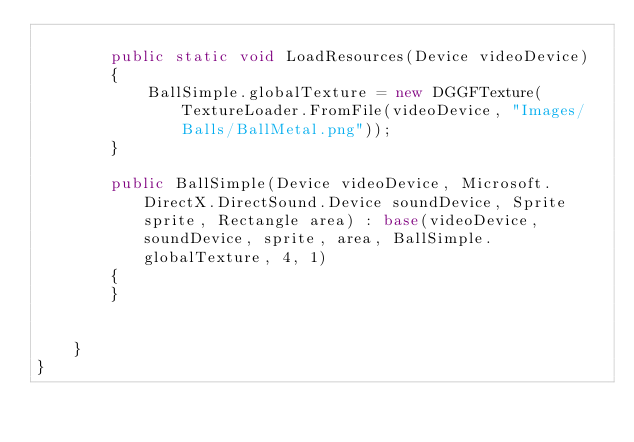Convert code to text. <code><loc_0><loc_0><loc_500><loc_500><_C#_>
		public static void LoadResources(Device videoDevice)
		{
			BallSimple.globalTexture = new DGGFTexture(TextureLoader.FromFile(videoDevice, "Images/Balls/BallMetal.png"));
		}

		public BallSimple(Device videoDevice, Microsoft.DirectX.DirectSound.Device soundDevice, Sprite sprite, Rectangle area) : base(videoDevice, soundDevice, sprite, area, BallSimple.globalTexture, 4, 1)
		{			
		}	


	}
}
</code> 